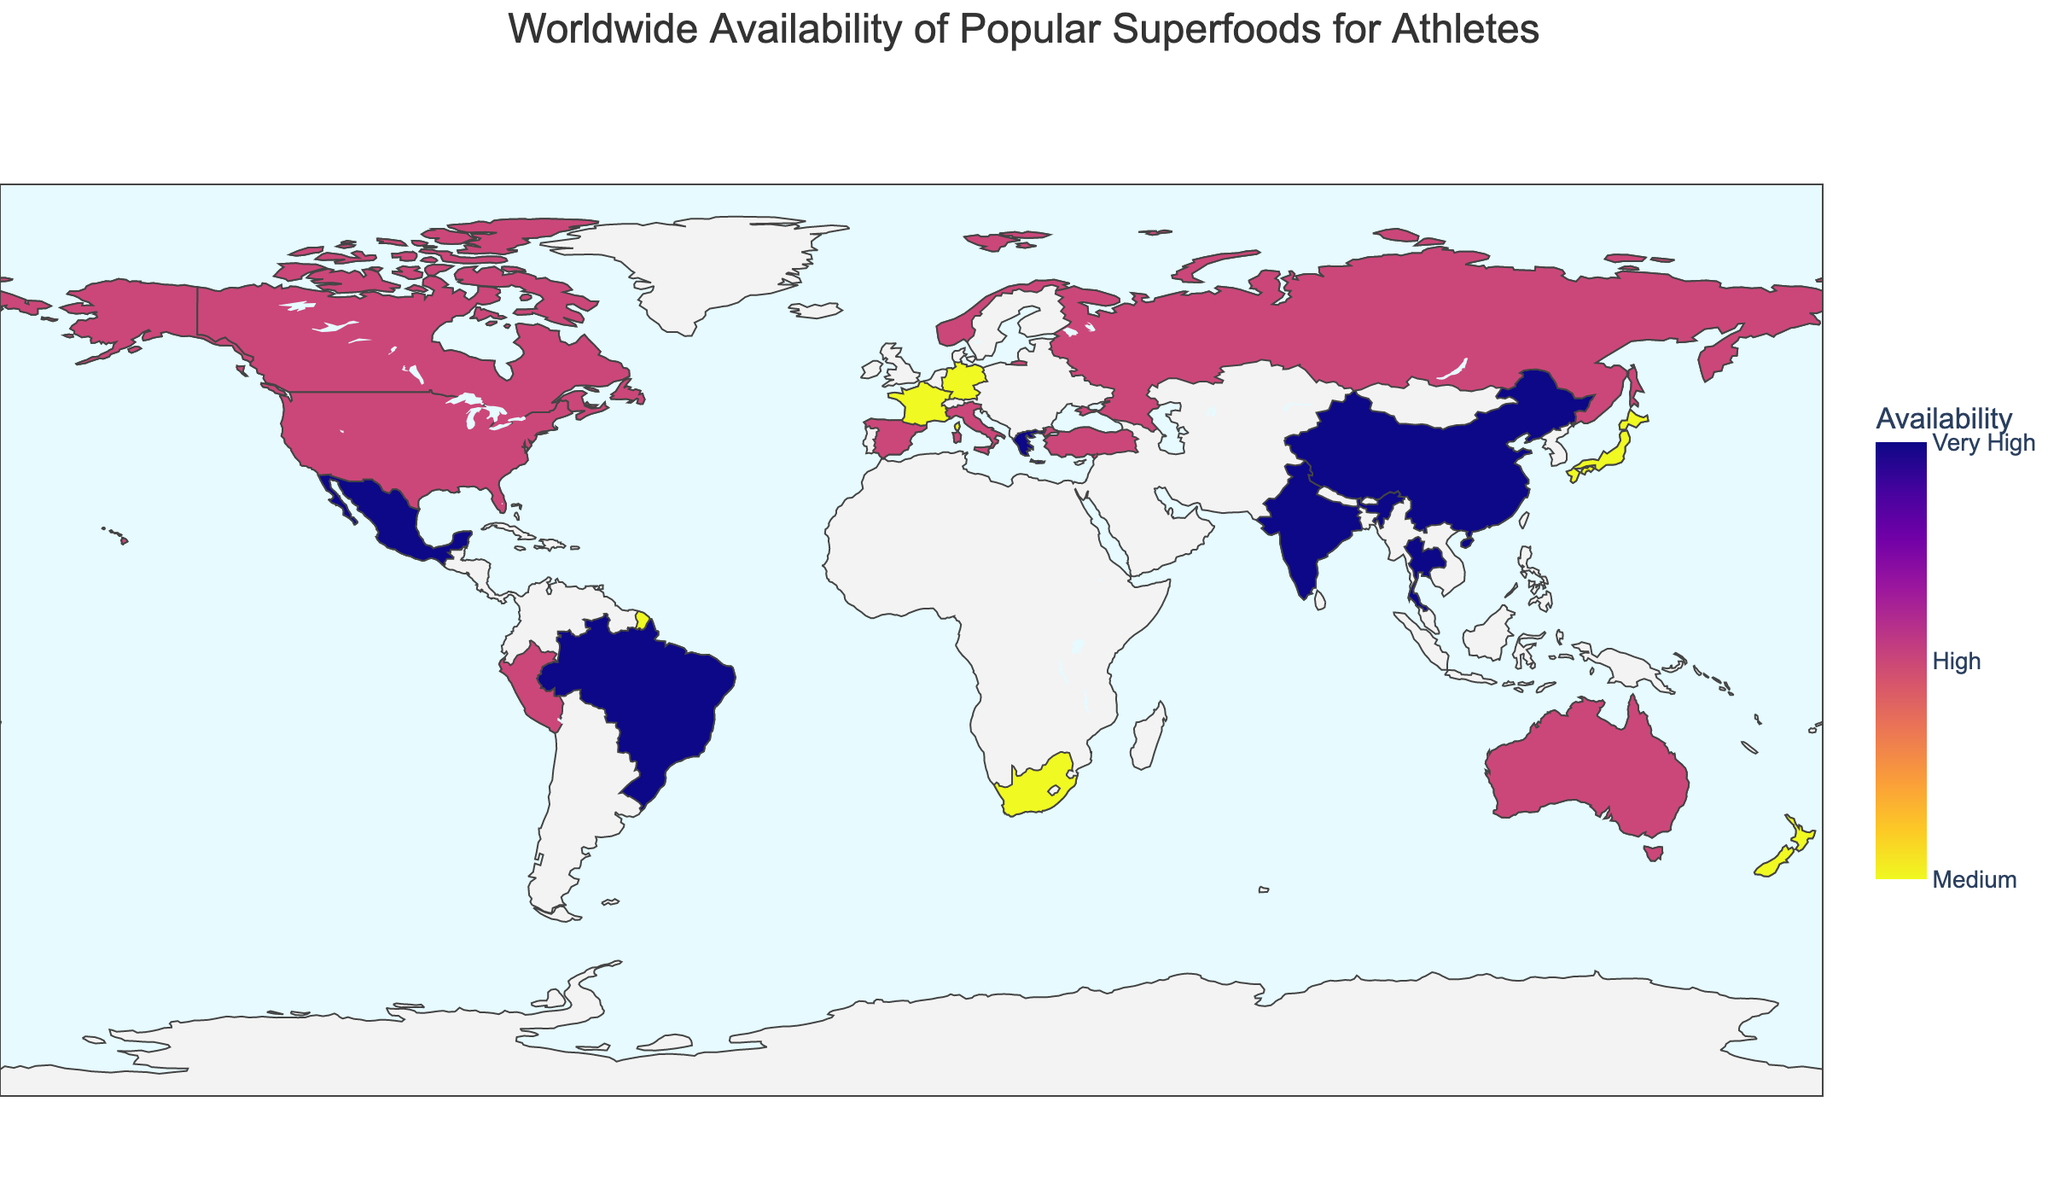What's the title of the geographic plot? The title is typically positioned at the top of the figure and provides an overview of the plot's theme. In this case, it conveys the content related to the availability of superfoods for athletes around the world.
Answer: Worldwide Availability of Popular Superfoods for Athletes How many countries have a 'Very High' availability of their respective superfood? Look at the color scale's legend, where 'Very High' is indicated. Then, count the number of countries colored with the corresponding color representing 'Very High' availability.
Answer: 8 Which country has the highest popularity rating for its superfood? Hover over each country to check the 'Popularity' rating. Identify the country with the maximum popularity score.
Answer: Greece What is the availability of Kale in Italy? To find this, locate Italy on the map and hover over it to see the detailed information for its superfood, which includes availability.
Answer: High Compare the popularity of Quinoa in the United States to that of Spirulina in Japan. Which is higher? Hover over the United States and Japan to view the popularity ratings for Quinoa and Spirulina, respectively, and compare the two values.
Answer: Quinoa What is the median popularity rating across all countries listed in the plot? First, list all popularity ratings: 85, 72, 95, 88, 90, 98, 80, 92, 87, 76, 89, 86, 93, 94, 70, 84, 75, 82, 78, 83. To find the median, sort these values and find the middle one. With 20 values, the median is the average of the 10th and 11th values in the sorted list. Sorted values: 70, 72, 75, 76, 78, 80, 82, 83, 84, 85, 86, 87, 88, 89, 90, 92, 93, 94, 95, 98. The 10th and 11th values are 85 and 86.
Answer: 85.5 Which country has a higher availability of its superfood, Mexico or Canada? Locate Mexico and Canada on the map, hover over each for details, and compare their availability ratings.
Answer: Mexico Identify any two countries with a 'Medium' availability of their superfood. Look for countries colored with the hue corresponding to 'Medium' availability. Consider components such as color coding and hover data to identify two countries.
Answer: Japan, Germany What is the average popularity rating for superfoods with 'High' availability? First, identify the countries with 'High' availability: USA, Australia, Peru, Norway, Spain, Canada, Italy, Turkey, Russia. Then, average their popularity ratings: (85 + 88 + 80 + 87 + 89 + 86 + 84 + 82 + 83) / 9. Sum these values to get 764, then divide by 9.
Answer: 84.89 How does the availability of Moringa in India compare with that of Buckwheat in Russia? Hover over both India and Russia to determine their 'Availability' rating, then compare them based on the color coding for 'Very High' and 'High' respectively.
Answer: Moringa has 'Very High' availability, Buckwheat has 'High' availability 